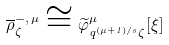Convert formula to latex. <formula><loc_0><loc_0><loc_500><loc_500>\overline { \rho } ^ { - , \, \mu } _ { \zeta } \cong \widetilde { \varphi } _ { q ^ { ( \mu + 1 ) / s } \zeta } ^ { \mu } [ \xi ]</formula> 